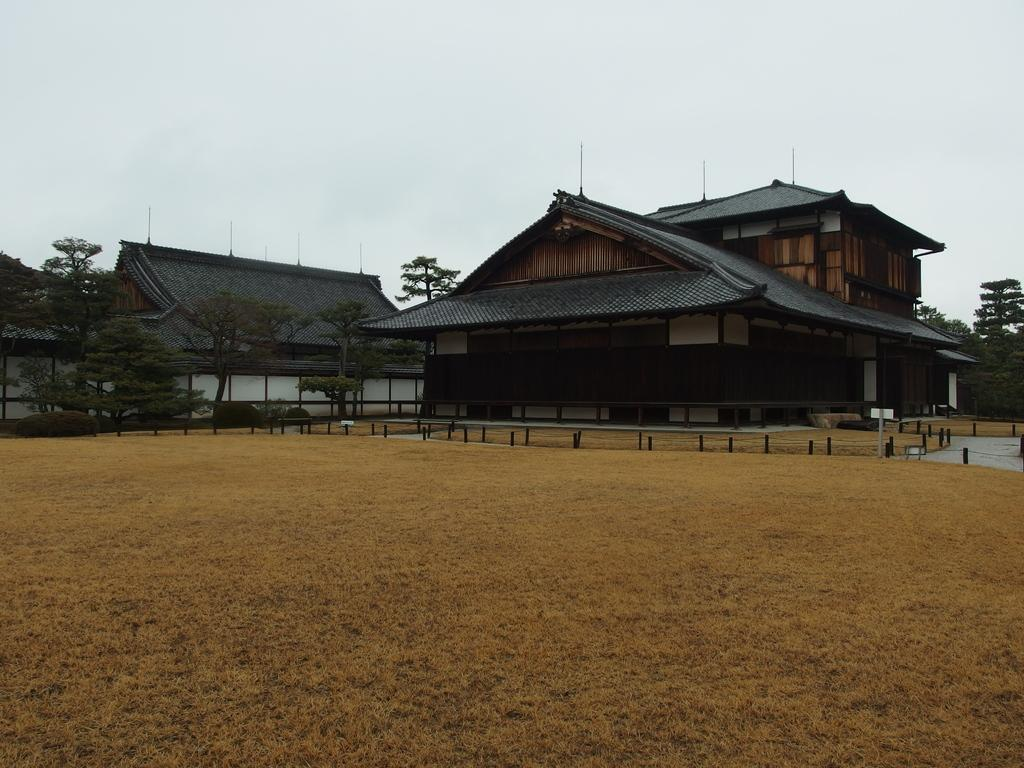What type of structures can be seen in the image? There are houses in the image. What is visible in front of the houses? There is ground visible in front of the houses. What type of vegetation is behind the houses? There are trees behind the houses. What is visible at the top of the image? The sky is visible at the top of the image. Where is the doctor located in the image? There is no doctor present in the image. What type of cloth is draped over the trees in the image? There is no cloth draped over the trees in the image. 